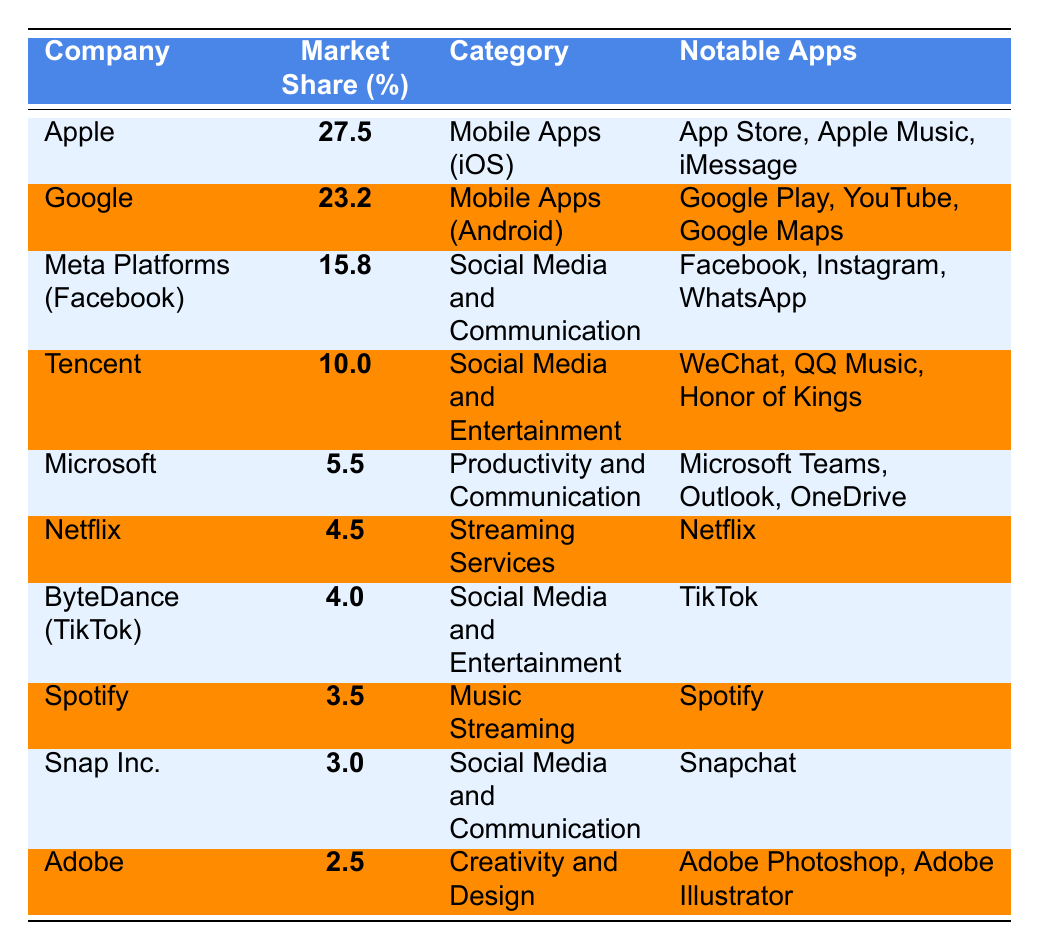What is the market share percentage of Apple? The table shows Apple has a market share percentage listed as **27.5**.
Answer: 27.5 Which company has the lowest market share percentage? By examining the percentages in the table, Adobe has the lowest at **2.5**.
Answer: 2.5 How many companies have a market share percentage of more than 10%? From the table, Apple, Google, Meta Platforms, and Tencent have market shares above 10% (4 companies total).
Answer: 4 Is Netflix a part of the Social Media category? According to the table, Netflix is categorized under Streaming Services, not Social Media.
Answer: No What is the combined market share percentage of Spotify and Snap Inc.? Adding their market shares gives (3.5 + 3.0) = 6.5.
Answer: 6.5 Which company has a notable app called TikTok? The table indicates that ByteDance is the company associated with the notable app TikTok.
Answer: ByteDance What is the difference between the market shares of Apple and Google? To find the difference, subtract Google's market share (23.2) from Apple's (27.5), resulting in (27.5 - 23.2) = 4.3.
Answer: 4.3 Is the market share of Adobe greater than that of Netflix? The table shows Adobe at 2.5 and Netflix at 4.5, so Adobe's market share is not greater (2.5 < 4.5).
Answer: No What percentage of the market share is captured by Meta Platforms compared to Microsoft? The market shares are 15.8 for Meta Platforms and 5.5 for Microsoft. The difference is (15.8 - 5.5) = 10.3, indicating Meta has significantly more.
Answer: 10.3 If you were to average the market share percentages of the top three companies, what would it be? The top three companies are Apple (27.5), Google (23.2), and Meta Platforms (15.8). Their total market share is (27.5 + 23.2 + 15.8) = 66.5. The average is 66.5 / 3 = 22.17.
Answer: 22.17 What is the total market share percentage of companies in the Social Media and Communication category? Adding the market shares of Meta Platforms (15.8), Tencent (10.0), and Snap Inc. (3.0) gives (15.8 + 10.0 + 3.0) = 28.8.
Answer: 28.8 